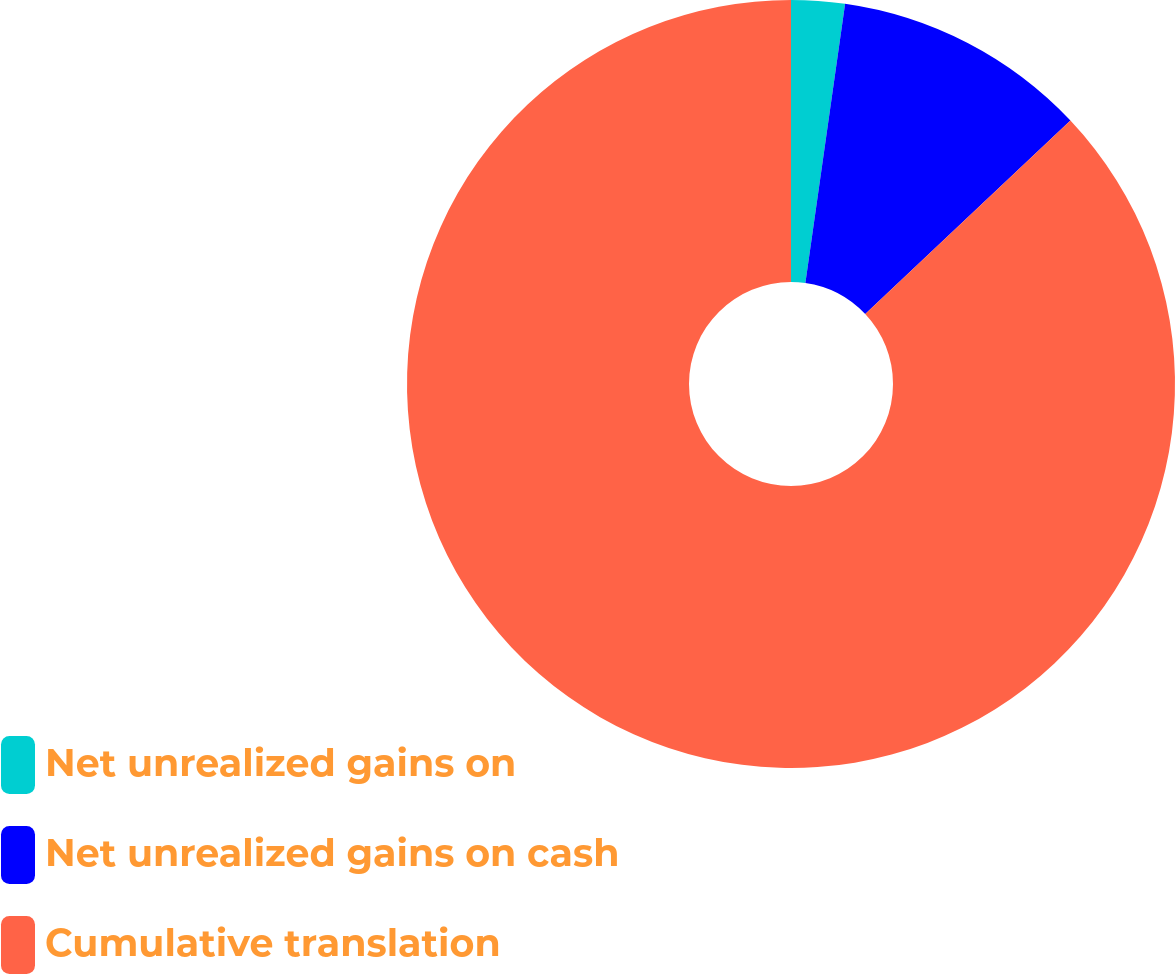<chart> <loc_0><loc_0><loc_500><loc_500><pie_chart><fcel>Net unrealized gains on<fcel>Net unrealized gains on cash<fcel>Cumulative translation<nl><fcel>2.25%<fcel>10.72%<fcel>87.03%<nl></chart> 